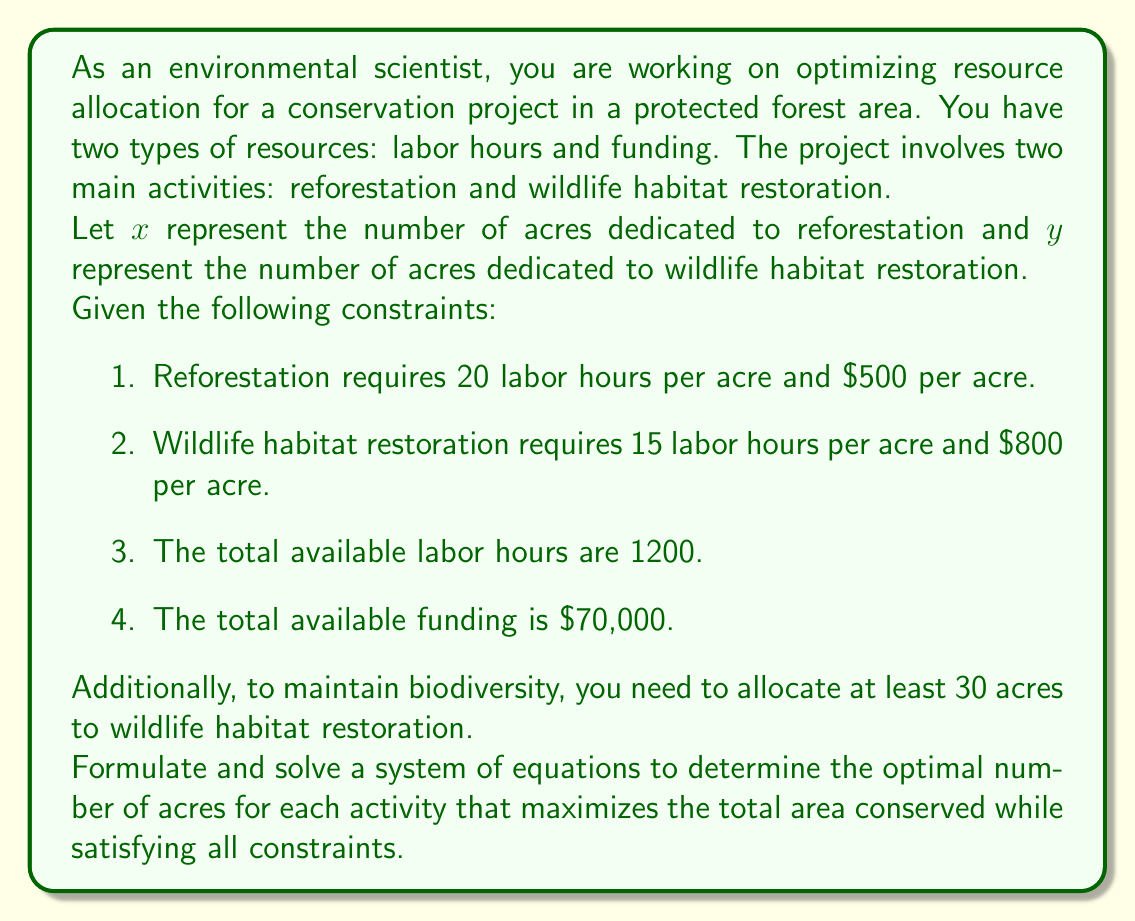Can you solve this math problem? Let's approach this step-by-step:

1) First, we need to formulate our system of equations based on the given constraints:

   Labor hours constraint: $20x + 15y = 1200$
   Funding constraint: $500x + 800y = 70000$
   Wildlife habitat minimum: $y \geq 30$

2) We want to maximize the total area conserved, which is $x + y$.

3) Let's solve the system of equations:

   From the labor hours constraint:
   $20x + 15y = 1200$
   $4x + 3y = 240$ (dividing by 5)

   From the funding constraint:
   $500x + 800y = 70000$
   $5x + 8y = 700$ (dividing by 100)

4) Now we have two equations:
   $4x + 3y = 240$
   $5x + 8y = 700$

5) Multiply the first equation by 5 and the second by -4:
   $20x + 15y = 1200$
   $-20x - 32y = -2800$

6) Add these equations:
   $-17y = -1600$
   $y = 94.12$

7) Substitute this value of $y$ back into $4x + 3y = 240$:
   $4x + 3(94.12) = 240$
   $4x + 282.36 = 240$
   $4x = -42.36$
   $x = -10.59$

8) However, $x$ cannot be negative. This means we need to consider the wildlife habitat minimum constraint. Let's set $y = 30$ (the minimum) and solve for $x$:

   $4x + 3(30) = 240$
   $4x + 90 = 240$
   $4x = 150$
   $x = 37.5$

9) Check if this solution satisfies the funding constraint:
   $500(37.5) + 800(30) = 18750 + 24000 = 42750$

   This is less than the available $70,000, so it's feasible.

Therefore, the optimal solution that satisfies all constraints is:
$x = 37.5$ acres for reforestation
$y = 30$ acres for wildlife habitat restoration

The total area conserved is $37.5 + 30 = 67.5$ acres.
Answer: The optimal allocation is 37.5 acres for reforestation and 30 acres for wildlife habitat restoration, conserving a total of 67.5 acres. 